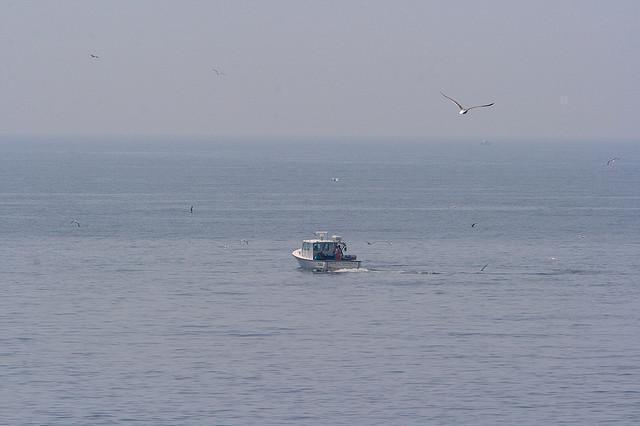What is the name of the object on top of the boat's roof?
Select the accurate answer and provide explanation: 'Answer: answer
Rationale: rationale.'
Options: Radio, booster, radar, antenna. Answer: antenna.
Rationale: It's an antenna. 